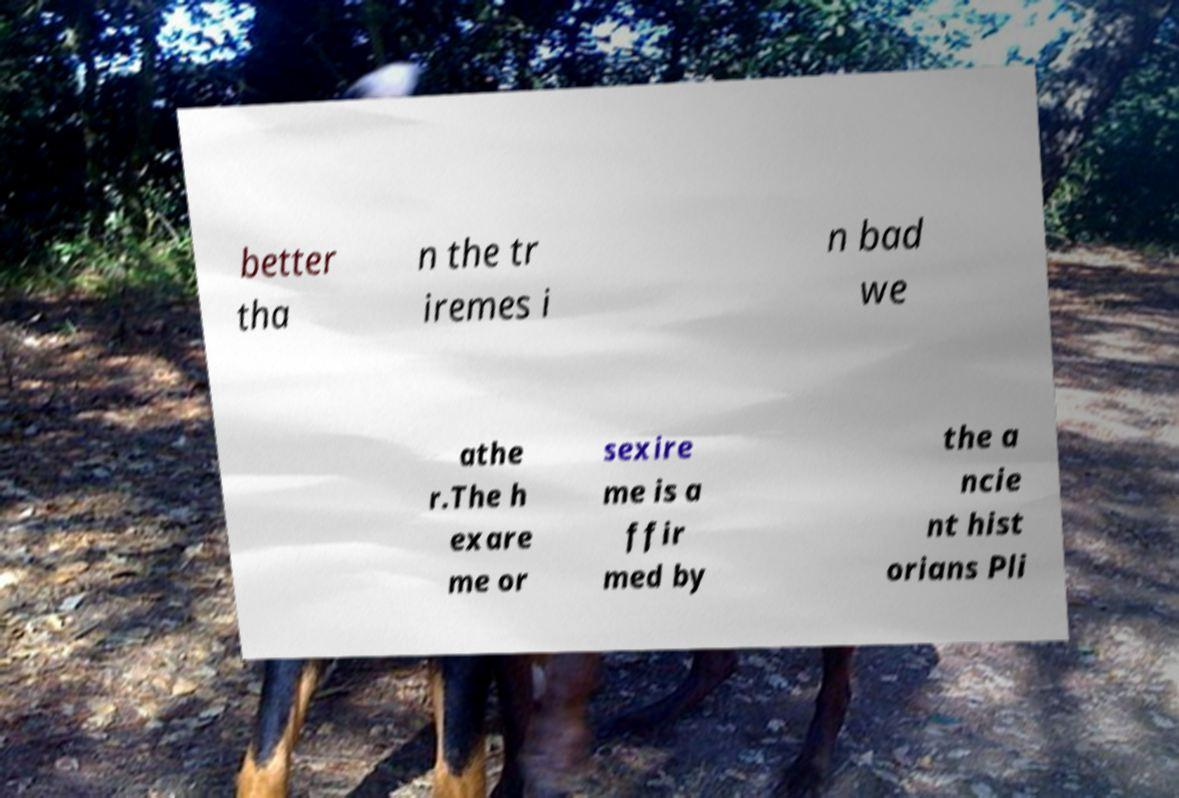Please read and relay the text visible in this image. What does it say? better tha n the tr iremes i n bad we athe r.The h exare me or sexire me is a ffir med by the a ncie nt hist orians Pli 